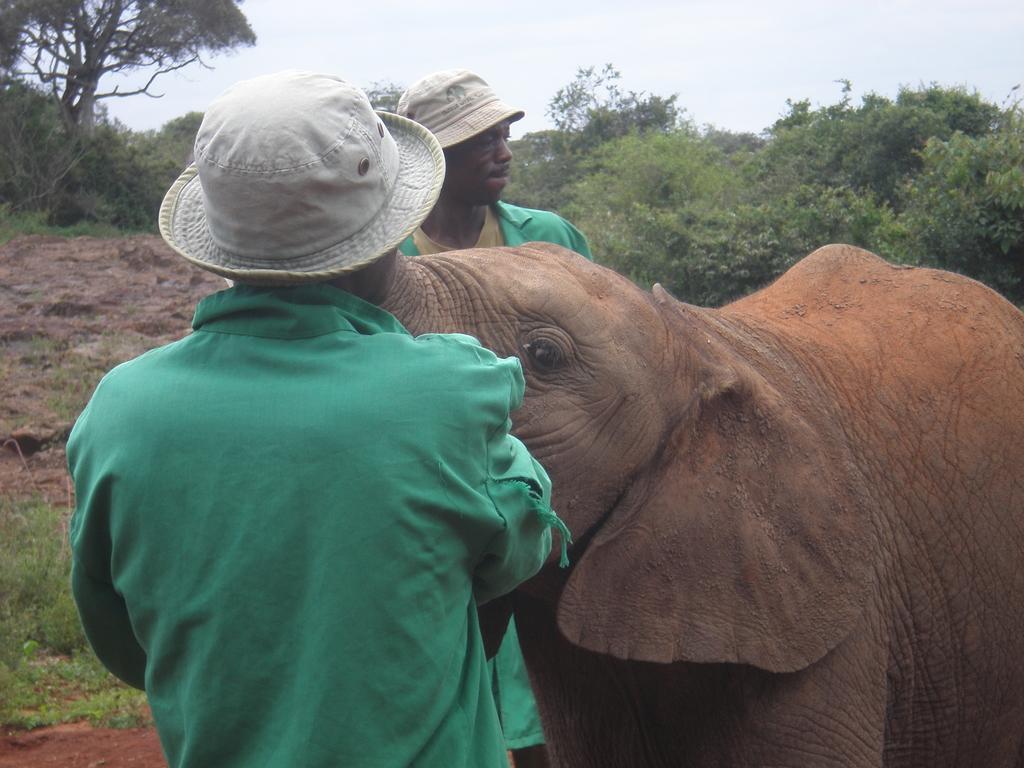Could you give a brief overview of what you see in this image? In the image I can see two people who are wearing the hats and a elephant beside them and also I can see some trees and plants. 